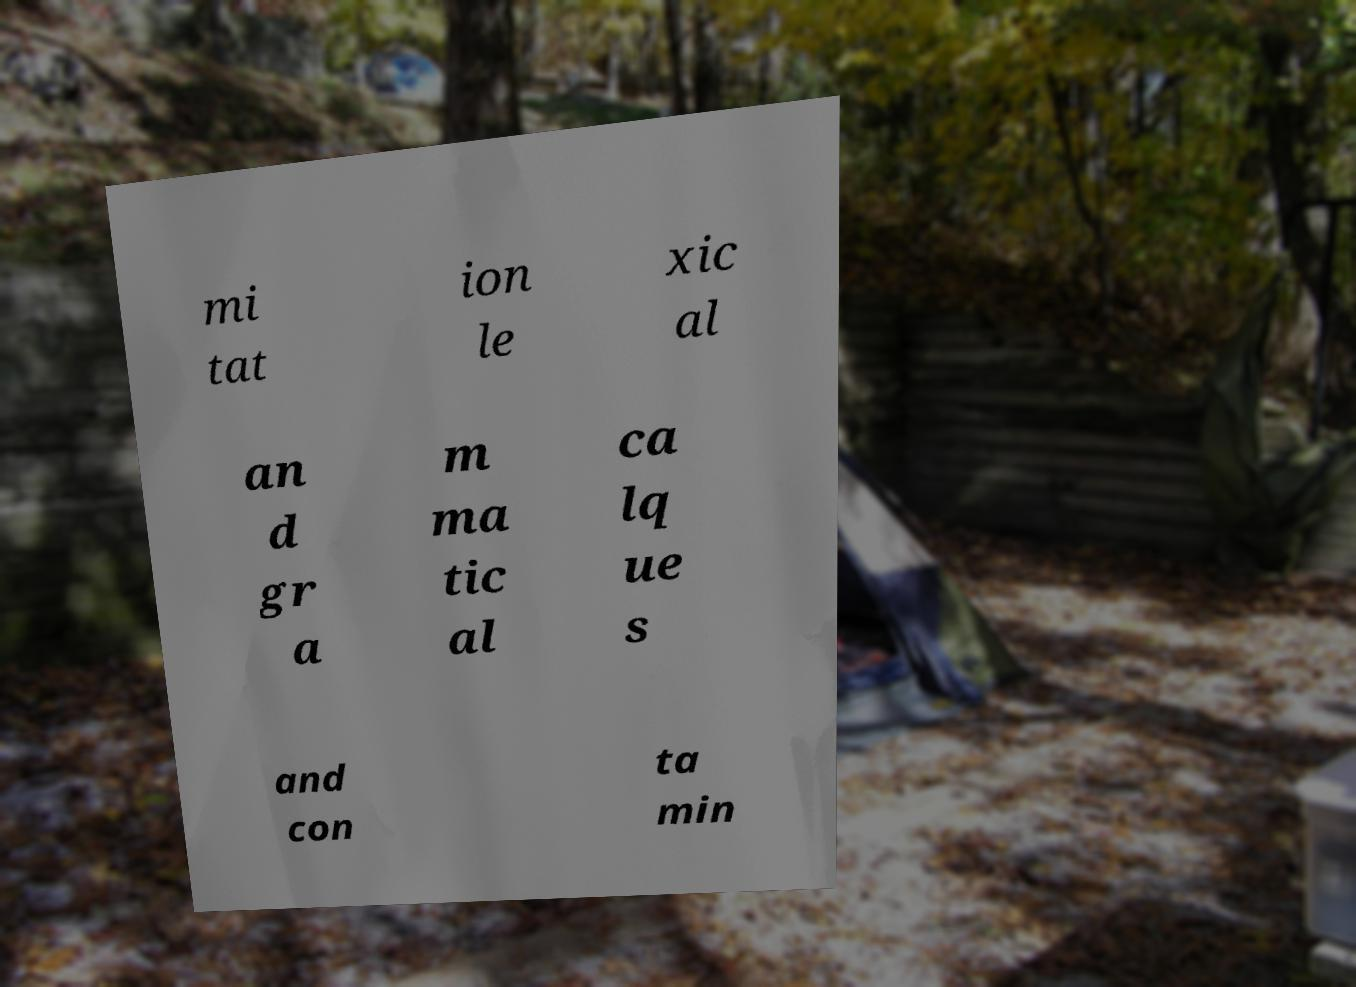Please identify and transcribe the text found in this image. mi tat ion le xic al an d gr a m ma tic al ca lq ue s and con ta min 